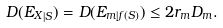Convert formula to latex. <formula><loc_0><loc_0><loc_500><loc_500>D ( { E _ { X } } _ { | S } ) = D ( E _ { m | f ( S ) } ) \leq 2 r _ { m } D _ { m } .</formula> 